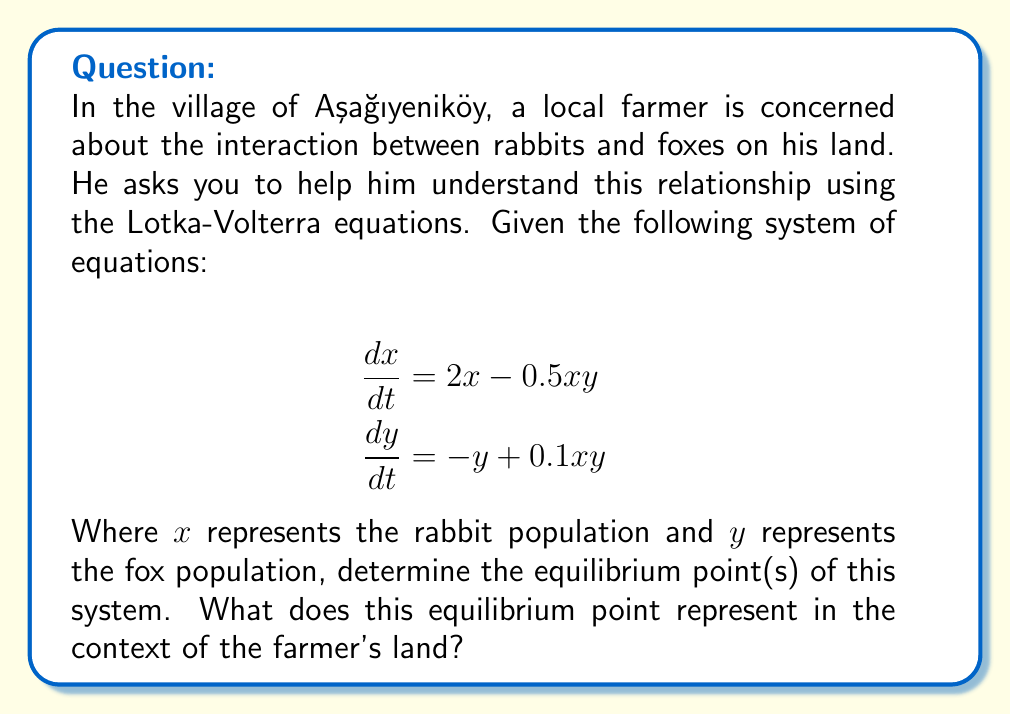Show me your answer to this math problem. To find the equilibrium point(s), we need to set both equations equal to zero and solve for x and y:

1) Set $\frac{dx}{dt} = 0$:
   $$2x - 0.5xy = 0$$
   $$x(2 - 0.5y) = 0$$
   This gives us two possibilities: $x = 0$ or $y = 4$

2) Set $\frac{dy}{dt} = 0$:
   $$-y + 0.1xy = 0$$
   $$y(-1 + 0.1x) = 0$$
   This gives us two possibilities: $y = 0$ or $x = 10$

3) Combining these results, we have two potential equilibrium points:
   (0, 0) and (10, 4)

4) The point (0, 0) represents extinction of both species, which is not of interest in this context.

5) The non-trivial equilibrium point is (10, 4), which means:
   - 10 rabbits
   - 4 foxes

This equilibrium point represents a stable coexistence of rabbits and foxes on the farmer's land. At this point, the rabbit population is sustaining itself and providing enough food for the fox population, while the fox population is keeping the rabbit population in check.
Answer: (10, 4) 